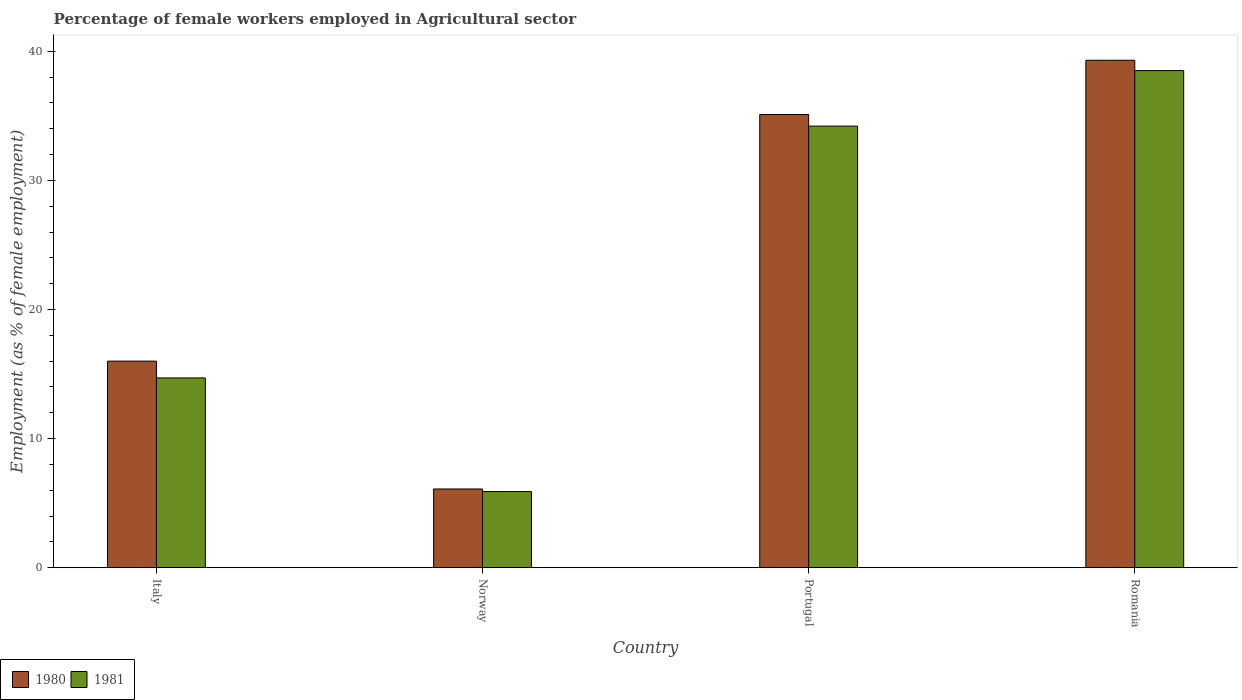Are the number of bars per tick equal to the number of legend labels?
Give a very brief answer. Yes. Are the number of bars on each tick of the X-axis equal?
Your answer should be compact. Yes. What is the label of the 1st group of bars from the left?
Offer a very short reply. Italy. In how many cases, is the number of bars for a given country not equal to the number of legend labels?
Your answer should be very brief. 0. What is the percentage of females employed in Agricultural sector in 1981 in Italy?
Give a very brief answer. 14.7. Across all countries, what is the maximum percentage of females employed in Agricultural sector in 1980?
Keep it short and to the point. 39.3. Across all countries, what is the minimum percentage of females employed in Agricultural sector in 1981?
Offer a terse response. 5.9. In which country was the percentage of females employed in Agricultural sector in 1980 maximum?
Ensure brevity in your answer.  Romania. What is the total percentage of females employed in Agricultural sector in 1981 in the graph?
Your response must be concise. 93.3. What is the difference between the percentage of females employed in Agricultural sector in 1981 in Portugal and that in Romania?
Your answer should be compact. -4.3. What is the difference between the percentage of females employed in Agricultural sector in 1981 in Norway and the percentage of females employed in Agricultural sector in 1980 in Italy?
Give a very brief answer. -10.1. What is the average percentage of females employed in Agricultural sector in 1980 per country?
Your response must be concise. 24.12. What is the difference between the percentage of females employed in Agricultural sector of/in 1980 and percentage of females employed in Agricultural sector of/in 1981 in Norway?
Offer a terse response. 0.2. In how many countries, is the percentage of females employed in Agricultural sector in 1981 greater than 6 %?
Provide a succinct answer. 3. What is the ratio of the percentage of females employed in Agricultural sector in 1981 in Norway to that in Romania?
Your answer should be very brief. 0.15. What is the difference between the highest and the second highest percentage of females employed in Agricultural sector in 1981?
Make the answer very short. -4.3. What is the difference between the highest and the lowest percentage of females employed in Agricultural sector in 1981?
Your answer should be very brief. 32.6. In how many countries, is the percentage of females employed in Agricultural sector in 1980 greater than the average percentage of females employed in Agricultural sector in 1980 taken over all countries?
Give a very brief answer. 2. Is the sum of the percentage of females employed in Agricultural sector in 1980 in Italy and Romania greater than the maximum percentage of females employed in Agricultural sector in 1981 across all countries?
Give a very brief answer. Yes. What does the 2nd bar from the left in Italy represents?
Give a very brief answer. 1981. Are the values on the major ticks of Y-axis written in scientific E-notation?
Your response must be concise. No. Does the graph contain any zero values?
Offer a terse response. No. How many legend labels are there?
Provide a short and direct response. 2. How are the legend labels stacked?
Your answer should be compact. Horizontal. What is the title of the graph?
Provide a succinct answer. Percentage of female workers employed in Agricultural sector. What is the label or title of the X-axis?
Offer a very short reply. Country. What is the label or title of the Y-axis?
Offer a very short reply. Employment (as % of female employment). What is the Employment (as % of female employment) in 1980 in Italy?
Provide a short and direct response. 16. What is the Employment (as % of female employment) in 1981 in Italy?
Provide a succinct answer. 14.7. What is the Employment (as % of female employment) of 1980 in Norway?
Offer a very short reply. 6.1. What is the Employment (as % of female employment) in 1981 in Norway?
Your answer should be very brief. 5.9. What is the Employment (as % of female employment) of 1980 in Portugal?
Offer a terse response. 35.1. What is the Employment (as % of female employment) in 1981 in Portugal?
Make the answer very short. 34.2. What is the Employment (as % of female employment) in 1980 in Romania?
Keep it short and to the point. 39.3. What is the Employment (as % of female employment) of 1981 in Romania?
Ensure brevity in your answer.  38.5. Across all countries, what is the maximum Employment (as % of female employment) of 1980?
Provide a short and direct response. 39.3. Across all countries, what is the maximum Employment (as % of female employment) in 1981?
Offer a very short reply. 38.5. Across all countries, what is the minimum Employment (as % of female employment) of 1980?
Your response must be concise. 6.1. Across all countries, what is the minimum Employment (as % of female employment) of 1981?
Your answer should be very brief. 5.9. What is the total Employment (as % of female employment) in 1980 in the graph?
Keep it short and to the point. 96.5. What is the total Employment (as % of female employment) of 1981 in the graph?
Offer a very short reply. 93.3. What is the difference between the Employment (as % of female employment) of 1980 in Italy and that in Portugal?
Ensure brevity in your answer.  -19.1. What is the difference between the Employment (as % of female employment) in 1981 in Italy and that in Portugal?
Provide a short and direct response. -19.5. What is the difference between the Employment (as % of female employment) of 1980 in Italy and that in Romania?
Keep it short and to the point. -23.3. What is the difference between the Employment (as % of female employment) of 1981 in Italy and that in Romania?
Your response must be concise. -23.8. What is the difference between the Employment (as % of female employment) in 1981 in Norway and that in Portugal?
Provide a succinct answer. -28.3. What is the difference between the Employment (as % of female employment) of 1980 in Norway and that in Romania?
Ensure brevity in your answer.  -33.2. What is the difference between the Employment (as % of female employment) of 1981 in Norway and that in Romania?
Your answer should be compact. -32.6. What is the difference between the Employment (as % of female employment) in 1980 in Italy and the Employment (as % of female employment) in 1981 in Portugal?
Offer a terse response. -18.2. What is the difference between the Employment (as % of female employment) of 1980 in Italy and the Employment (as % of female employment) of 1981 in Romania?
Give a very brief answer. -22.5. What is the difference between the Employment (as % of female employment) in 1980 in Norway and the Employment (as % of female employment) in 1981 in Portugal?
Make the answer very short. -28.1. What is the difference between the Employment (as % of female employment) of 1980 in Norway and the Employment (as % of female employment) of 1981 in Romania?
Offer a terse response. -32.4. What is the average Employment (as % of female employment) of 1980 per country?
Make the answer very short. 24.12. What is the average Employment (as % of female employment) of 1981 per country?
Offer a very short reply. 23.32. What is the difference between the Employment (as % of female employment) in 1980 and Employment (as % of female employment) in 1981 in Italy?
Your answer should be compact. 1.3. What is the difference between the Employment (as % of female employment) of 1980 and Employment (as % of female employment) of 1981 in Portugal?
Provide a short and direct response. 0.9. What is the ratio of the Employment (as % of female employment) in 1980 in Italy to that in Norway?
Make the answer very short. 2.62. What is the ratio of the Employment (as % of female employment) of 1981 in Italy to that in Norway?
Provide a succinct answer. 2.49. What is the ratio of the Employment (as % of female employment) of 1980 in Italy to that in Portugal?
Offer a very short reply. 0.46. What is the ratio of the Employment (as % of female employment) in 1981 in Italy to that in Portugal?
Offer a very short reply. 0.43. What is the ratio of the Employment (as % of female employment) in 1980 in Italy to that in Romania?
Your answer should be very brief. 0.41. What is the ratio of the Employment (as % of female employment) of 1981 in Italy to that in Romania?
Ensure brevity in your answer.  0.38. What is the ratio of the Employment (as % of female employment) in 1980 in Norway to that in Portugal?
Your answer should be compact. 0.17. What is the ratio of the Employment (as % of female employment) of 1981 in Norway to that in Portugal?
Provide a succinct answer. 0.17. What is the ratio of the Employment (as % of female employment) in 1980 in Norway to that in Romania?
Offer a terse response. 0.16. What is the ratio of the Employment (as % of female employment) of 1981 in Norway to that in Romania?
Your answer should be compact. 0.15. What is the ratio of the Employment (as % of female employment) in 1980 in Portugal to that in Romania?
Offer a terse response. 0.89. What is the ratio of the Employment (as % of female employment) of 1981 in Portugal to that in Romania?
Provide a succinct answer. 0.89. What is the difference between the highest and the second highest Employment (as % of female employment) of 1981?
Give a very brief answer. 4.3. What is the difference between the highest and the lowest Employment (as % of female employment) in 1980?
Your answer should be compact. 33.2. What is the difference between the highest and the lowest Employment (as % of female employment) of 1981?
Make the answer very short. 32.6. 